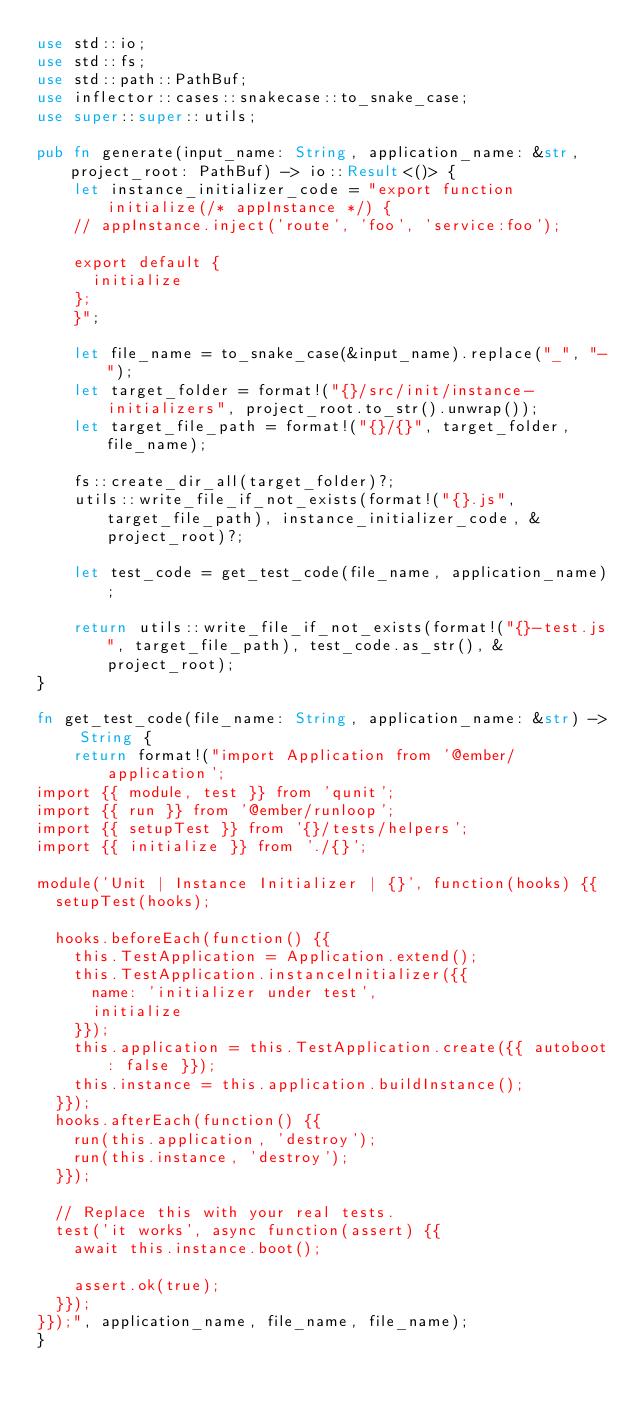<code> <loc_0><loc_0><loc_500><loc_500><_Rust_>use std::io;
use std::fs;
use std::path::PathBuf;
use inflector::cases::snakecase::to_snake_case;
use super::super::utils;

pub fn generate(input_name: String, application_name: &str, project_root: PathBuf) -> io::Result<()> {
    let instance_initializer_code = "export function initialize(/* appInstance */) {
    // appInstance.inject('route', 'foo', 'service:foo');

    export default {
      initialize
    };
    }";

    let file_name = to_snake_case(&input_name).replace("_", "-");
    let target_folder = format!("{}/src/init/instance-initializers", project_root.to_str().unwrap());
    let target_file_path = format!("{}/{}", target_folder, file_name);

    fs::create_dir_all(target_folder)?;
    utils::write_file_if_not_exists(format!("{}.js", target_file_path), instance_initializer_code, &project_root)?;

    let test_code = get_test_code(file_name, application_name);

    return utils::write_file_if_not_exists(format!("{}-test.js", target_file_path), test_code.as_str(), &project_root);
}

fn get_test_code(file_name: String, application_name: &str) -> String {
    return format!("import Application from '@ember/application';
import {{ module, test }} from 'qunit';
import {{ run }} from '@ember/runloop';
import {{ setupTest }} from '{}/tests/helpers';
import {{ initialize }} from './{}';

module('Unit | Instance Initializer | {}', function(hooks) {{
  setupTest(hooks);

  hooks.beforeEach(function() {{
    this.TestApplication = Application.extend();
    this.TestApplication.instanceInitializer({{
      name: 'initializer under test',
      initialize
    }});
    this.application = this.TestApplication.create({{ autoboot: false }});
    this.instance = this.application.buildInstance();
  }});
  hooks.afterEach(function() {{
    run(this.application, 'destroy');
    run(this.instance, 'destroy');
  }});

  // Replace this with your real tests.
  test('it works', async function(assert) {{
    await this.instance.boot();

    assert.ok(true);
  }});
}});", application_name, file_name, file_name);
}

</code> 